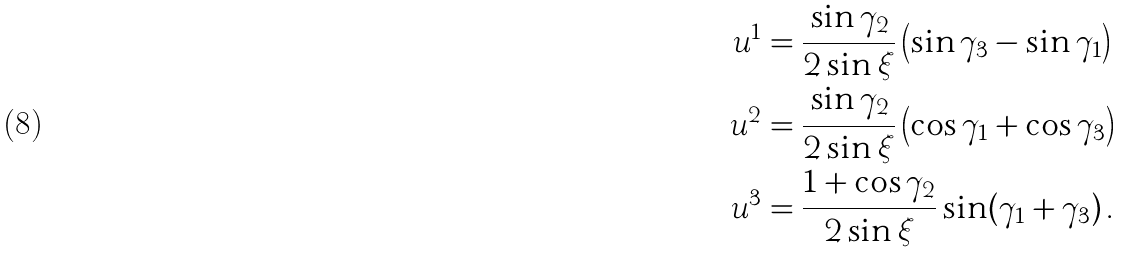Convert formula to latex. <formula><loc_0><loc_0><loc_500><loc_500>u ^ { 1 } & = \frac { \sin \gamma _ { 2 } } { 2 \sin \xi } \left ( \sin \gamma _ { 3 } - \sin \gamma _ { 1 } \right ) \\ u ^ { 2 } & = \frac { \sin \gamma _ { 2 } } { 2 \sin \xi } \left ( \cos \gamma _ { 1 } + \cos \gamma _ { 3 } \right ) \\ u ^ { 3 } & = \frac { 1 + \cos \gamma _ { 2 } } { 2 \sin \xi } \sin ( \gamma _ { 1 } + \gamma _ { 3 } ) \, .</formula> 